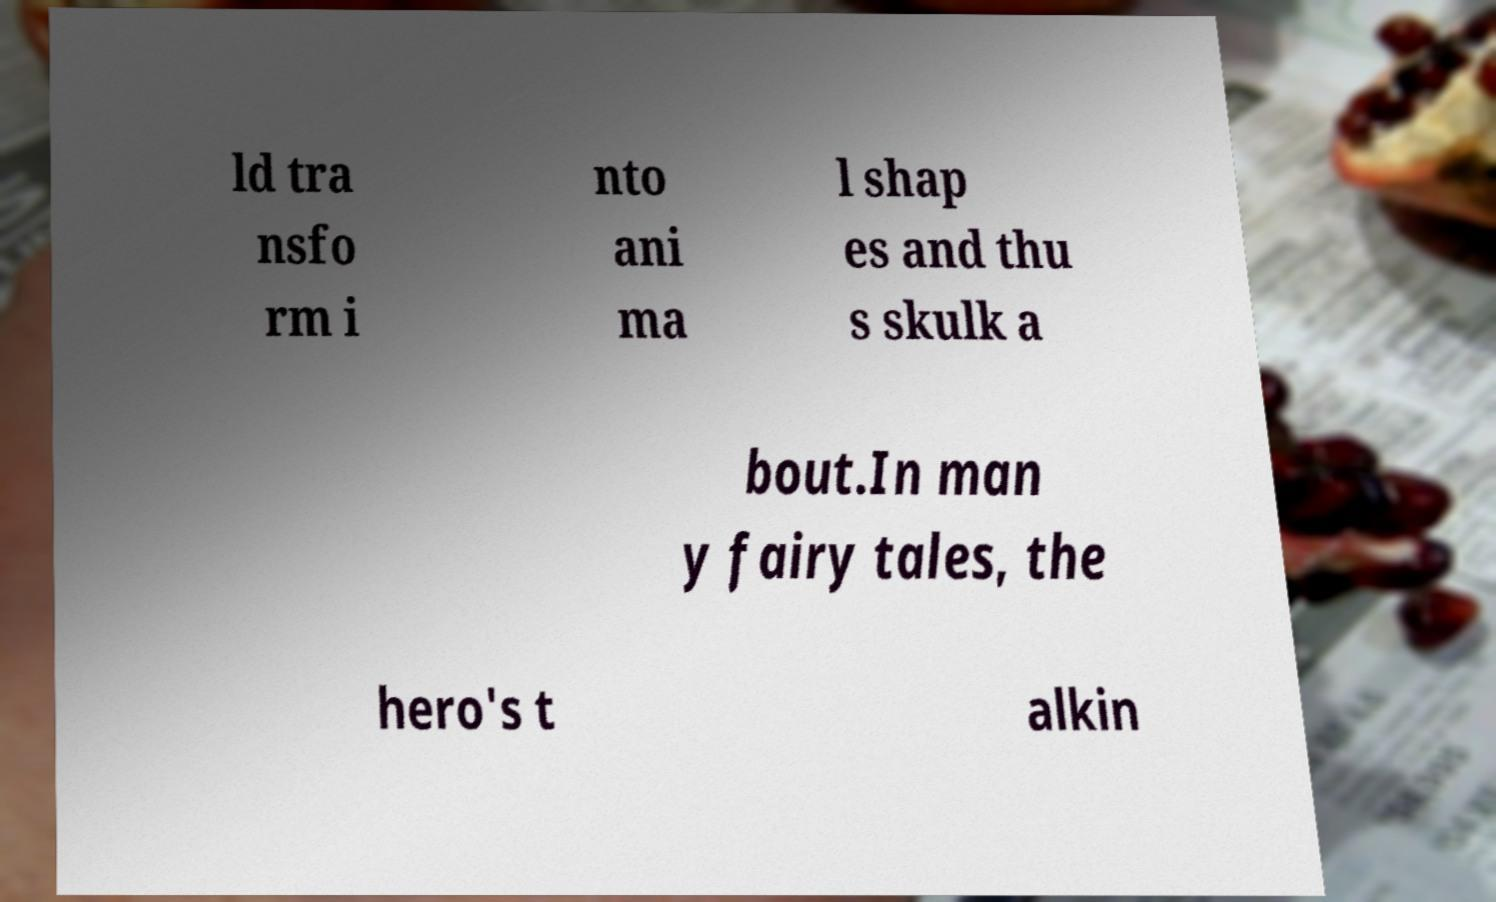Could you assist in decoding the text presented in this image and type it out clearly? ld tra nsfo rm i nto ani ma l shap es and thu s skulk a bout.In man y fairy tales, the hero's t alkin 